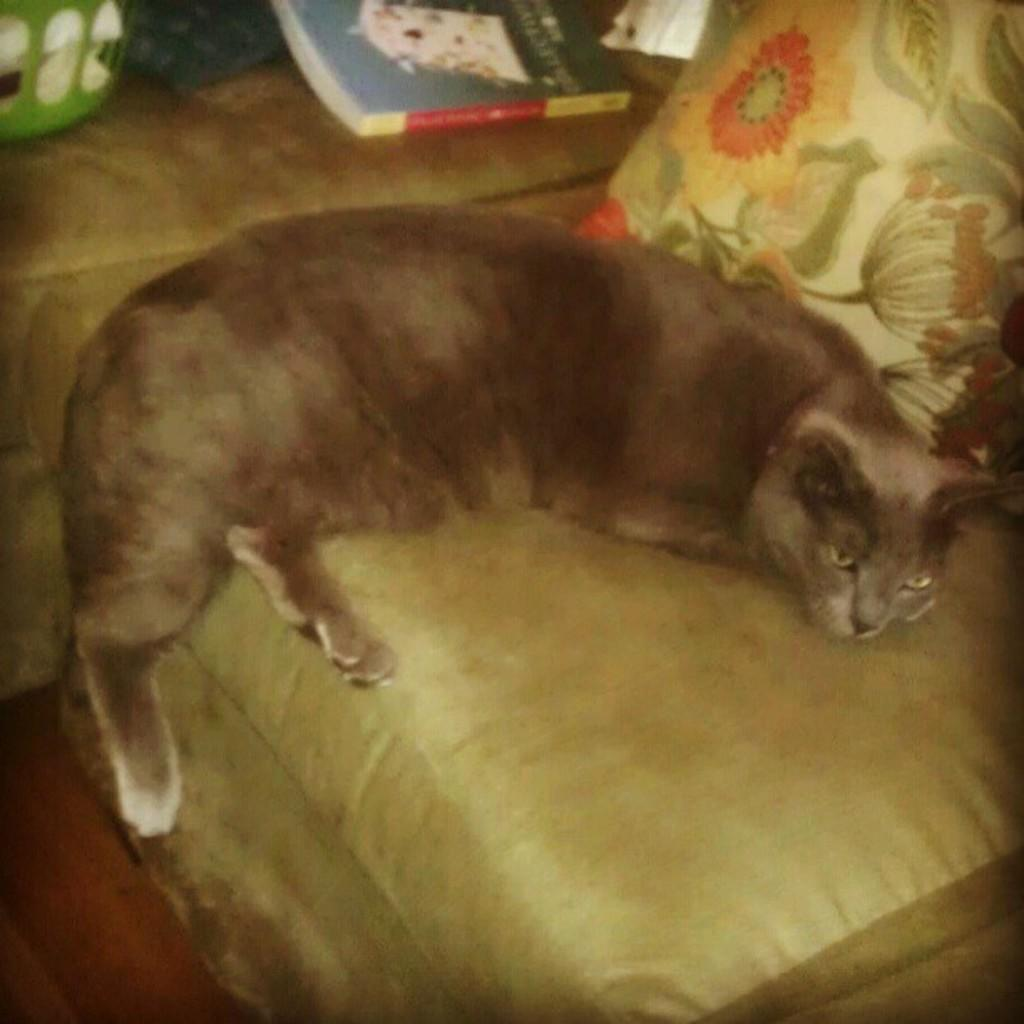What type of furniture is in the image? There is a sofa in the image. What is sitting on the sofa? A cat is sitting on the sofa. What color is the object in the image? There is a green-colored object in the image. What is used for comfort on the sofa? There is a cushion in the image. What is the angle of the slope in the image? There is no slope present in the image. How is the cat measuring the distance between the cushion and the green-colored object? The image does not show the cat measuring anything; it is simply sitting on the sofa. 